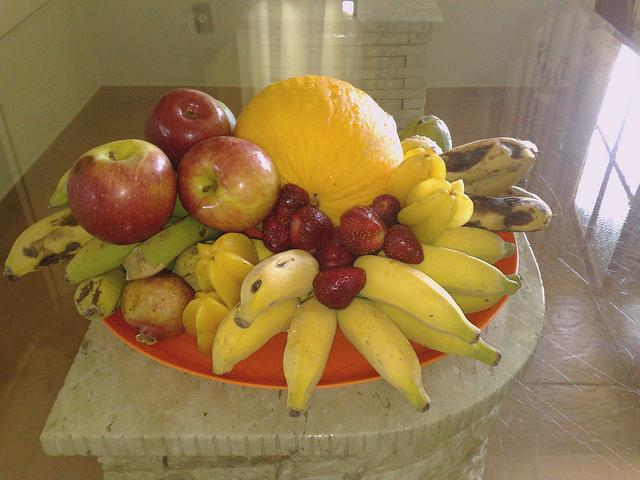What color is the largest fruit on the plate? yellow 